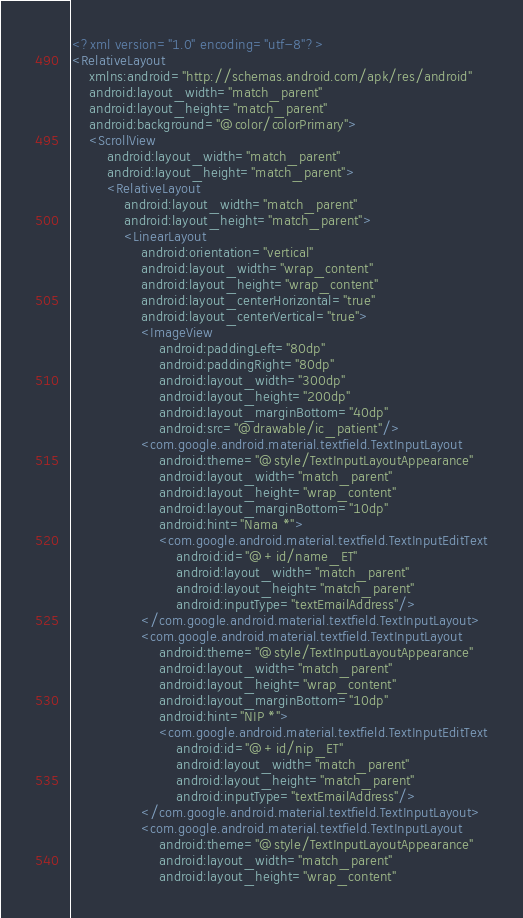Convert code to text. <code><loc_0><loc_0><loc_500><loc_500><_XML_><?xml version="1.0" encoding="utf-8"?>
<RelativeLayout
    xmlns:android="http://schemas.android.com/apk/res/android"
    android:layout_width="match_parent"
    android:layout_height="match_parent"
    android:background="@color/colorPrimary">
    <ScrollView
        android:layout_width="match_parent"
        android:layout_height="match_parent">
        <RelativeLayout
            android:layout_width="match_parent"
            android:layout_height="match_parent">
            <LinearLayout
                android:orientation="vertical"
                android:layout_width="wrap_content"
                android:layout_height="wrap_content"
                android:layout_centerHorizontal="true"
                android:layout_centerVertical="true">
                <ImageView
                    android:paddingLeft="80dp"
                    android:paddingRight="80dp"
                    android:layout_width="300dp"
                    android:layout_height="200dp"
                    android:layout_marginBottom="40dp"
                    android:src="@drawable/ic_patient"/>
                <com.google.android.material.textfield.TextInputLayout
                    android:theme="@style/TextInputLayoutAppearance"
                    android:layout_width="match_parent"
                    android:layout_height="wrap_content"
                    android:layout_marginBottom="10dp"
                    android:hint="Nama *">
                    <com.google.android.material.textfield.TextInputEditText
                        android:id="@+id/name_ET"
                        android:layout_width="match_parent"
                        android:layout_height="match_parent"
                        android:inputType="textEmailAddress"/>
                </com.google.android.material.textfield.TextInputLayout>
                <com.google.android.material.textfield.TextInputLayout
                    android:theme="@style/TextInputLayoutAppearance"
                    android:layout_width="match_parent"
                    android:layout_height="wrap_content"
                    android:layout_marginBottom="10dp"
                    android:hint="NIP *">
                    <com.google.android.material.textfield.TextInputEditText
                        android:id="@+id/nip_ET"
                        android:layout_width="match_parent"
                        android:layout_height="match_parent"
                        android:inputType="textEmailAddress"/>
                </com.google.android.material.textfield.TextInputLayout>
                <com.google.android.material.textfield.TextInputLayout
                    android:theme="@style/TextInputLayoutAppearance"
                    android:layout_width="match_parent"
                    android:layout_height="wrap_content"</code> 